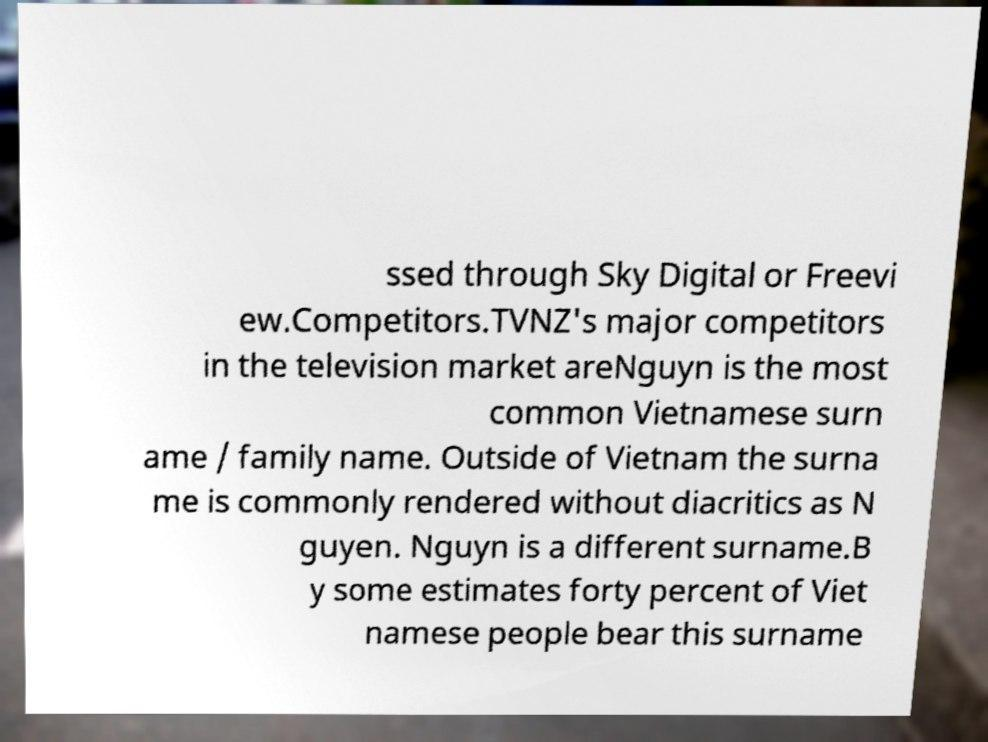Could you extract and type out the text from this image? ssed through Sky Digital or Freevi ew.Competitors.TVNZ's major competitors in the television market areNguyn is the most common Vietnamese surn ame / family name. Outside of Vietnam the surna me is commonly rendered without diacritics as N guyen. Nguyn is a different surname.B y some estimates forty percent of Viet namese people bear this surname 